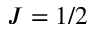<formula> <loc_0><loc_0><loc_500><loc_500>J = 1 / 2</formula> 